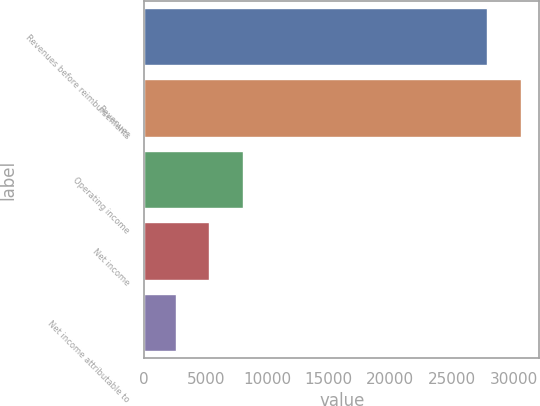Convert chart to OTSL. <chart><loc_0><loc_0><loc_500><loc_500><bar_chart><fcel>Revenues before reimbursements<fcel>Revenues<fcel>Operating income<fcel>Net income<fcel>Net income attributable to<nl><fcel>27862<fcel>30584.4<fcel>7998.8<fcel>5276.4<fcel>2554<nl></chart> 